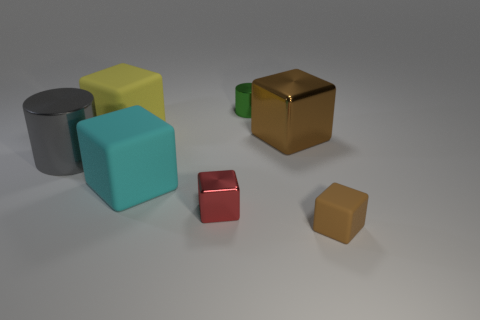Can you describe the size and arrangement of the objects in the image? The image displays six three-dimensional objects varying in size and color, arranged haphazardly on a flat surface. These shapes include a large cube, a medium cylinder, and small cubes, one of which is directly in front of the cylinder.  What colors are these objects, and do they suggest anything about the material they are composed of? The objects exhibit a range of colors: gray, yellow, turquoise, gold, red, and brown. Their colors, combined with their matte and shiny surfaces, suggest that they could be made from materials like plastic, metal, or painted ceramic. 